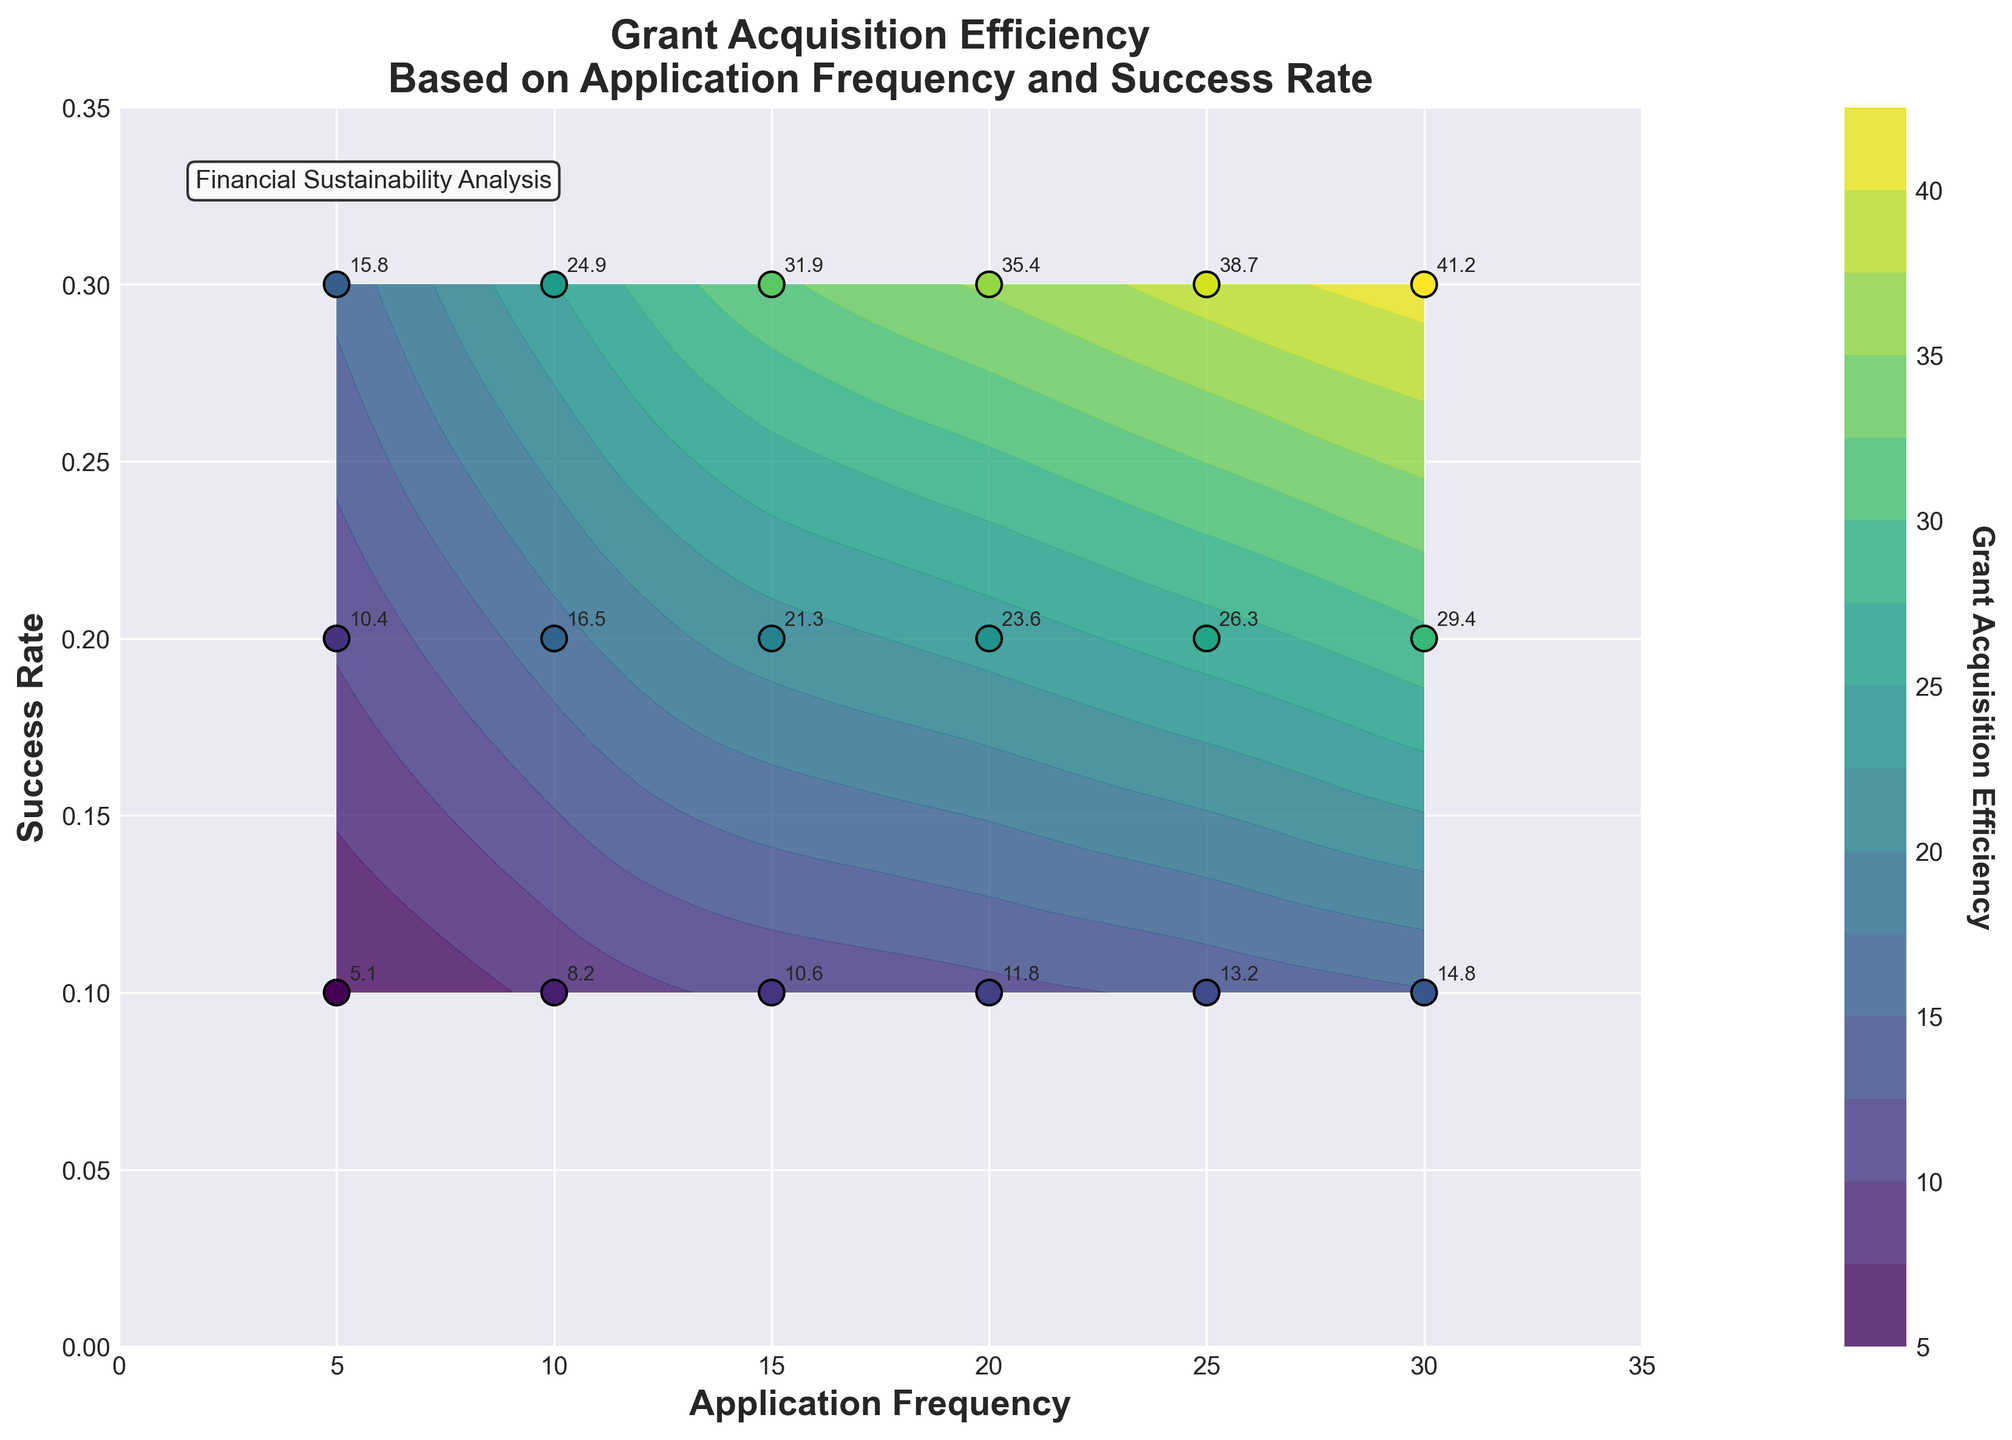How many data points are shown in the scatter plot? By looking at the plot, we can count the number of scatter points (the black-edged circles). We observe 15 such points.
Answer: 15 What is the highest value of Grant Acquisition Efficiency depicted on the plot? By examining the annotation labels on the scatter points, the highest value is found to be 41.2.
Answer: 41.2 What is the Success Rate range depicted on the y-axis? The y-axis is labeled and spans from 0 to 0.35, as indicated by the tick marks and axis labels.
Answer: 0 to 0.35 What happens to Grant Acquisition Efficiency as Application Frequency increases from 5 to 30, given a fixed Success Rate of 0.3? Focusing on the labels above the scatter points and isolating those with a Success Rate of 0.3, we see the Efficiency increases from 15.8 to 41.2 as Application Frequency increases from 5 to 30.
Answer: It increases Which Application Frequency and Success Rate combination yields an efficiency closest to 10? Looking at the scatter point annotations and identifying the value closest to 10, we see that the combination (10, 0.1) provides an efficiency of 10.6, which is closest to 10.
Answer: (10, 0.1) Is there a pattern in Grant Acquisition Efficiency as Success Rate changes from 0.1 to 0.3 while keeping Application Frequency constant? Observing the annotated efficiency values at given frequencies (e.g., 5, 10, 15, 20, 25, 30), we see an increasing trend in efficiency as Success Rate increases from 0.1 to 0.3 at each of these Application Frequencies.
Answer: Yes, it increases How does Grant Acquisition Efficiency at an Application Frequency of 25 and Success Rate of 0.3 compare to that at an Application Frequency of 5 and Success Rate of 0.3? We compare the annotations of the corresponding scatter points. Efficiency is 38.7 at (25, 0.3) and 15.8 at (5, 0.3), showing a clear increase.
Answer: 38.7 is higher than 15.8 Which color represents higher Grant Acquisition Efficiency, and what does a shift from one color to another indicate? By examining the color bar on the right, darker shades (purple) represent lower efficiency and lighter shades (yellow) indicate higher efficiency. A shift from dark to light colors on the contour plot represents increasing efficiency.
Answer: Lighter colors represent higher efficiency If an organization is aiming for an efficiency around 20, what Success Rate and Application Frequency should they target? By checking the plot for efficiency values close to 20 and observing their corresponding frequency and success rate, the point (15, 0.2) yields an efficiency of 21.3 which is closest to 20.
Answer: (15, 0.2) What does the contour line pattern suggest about the relationship between Application Frequency, Success Rate, and Grant Acquisition Efficiency? Contour lines demonstrate the gradient in efficiency. Denser contours signify rapid changes whereas sparse contours indicate gradual changes. Lines generally indicate that increasing both Application Frequency and Success Rate correlates with higher Grant Acquisition Efficiency.
Answer: Increasing both leads to higher efficiency 